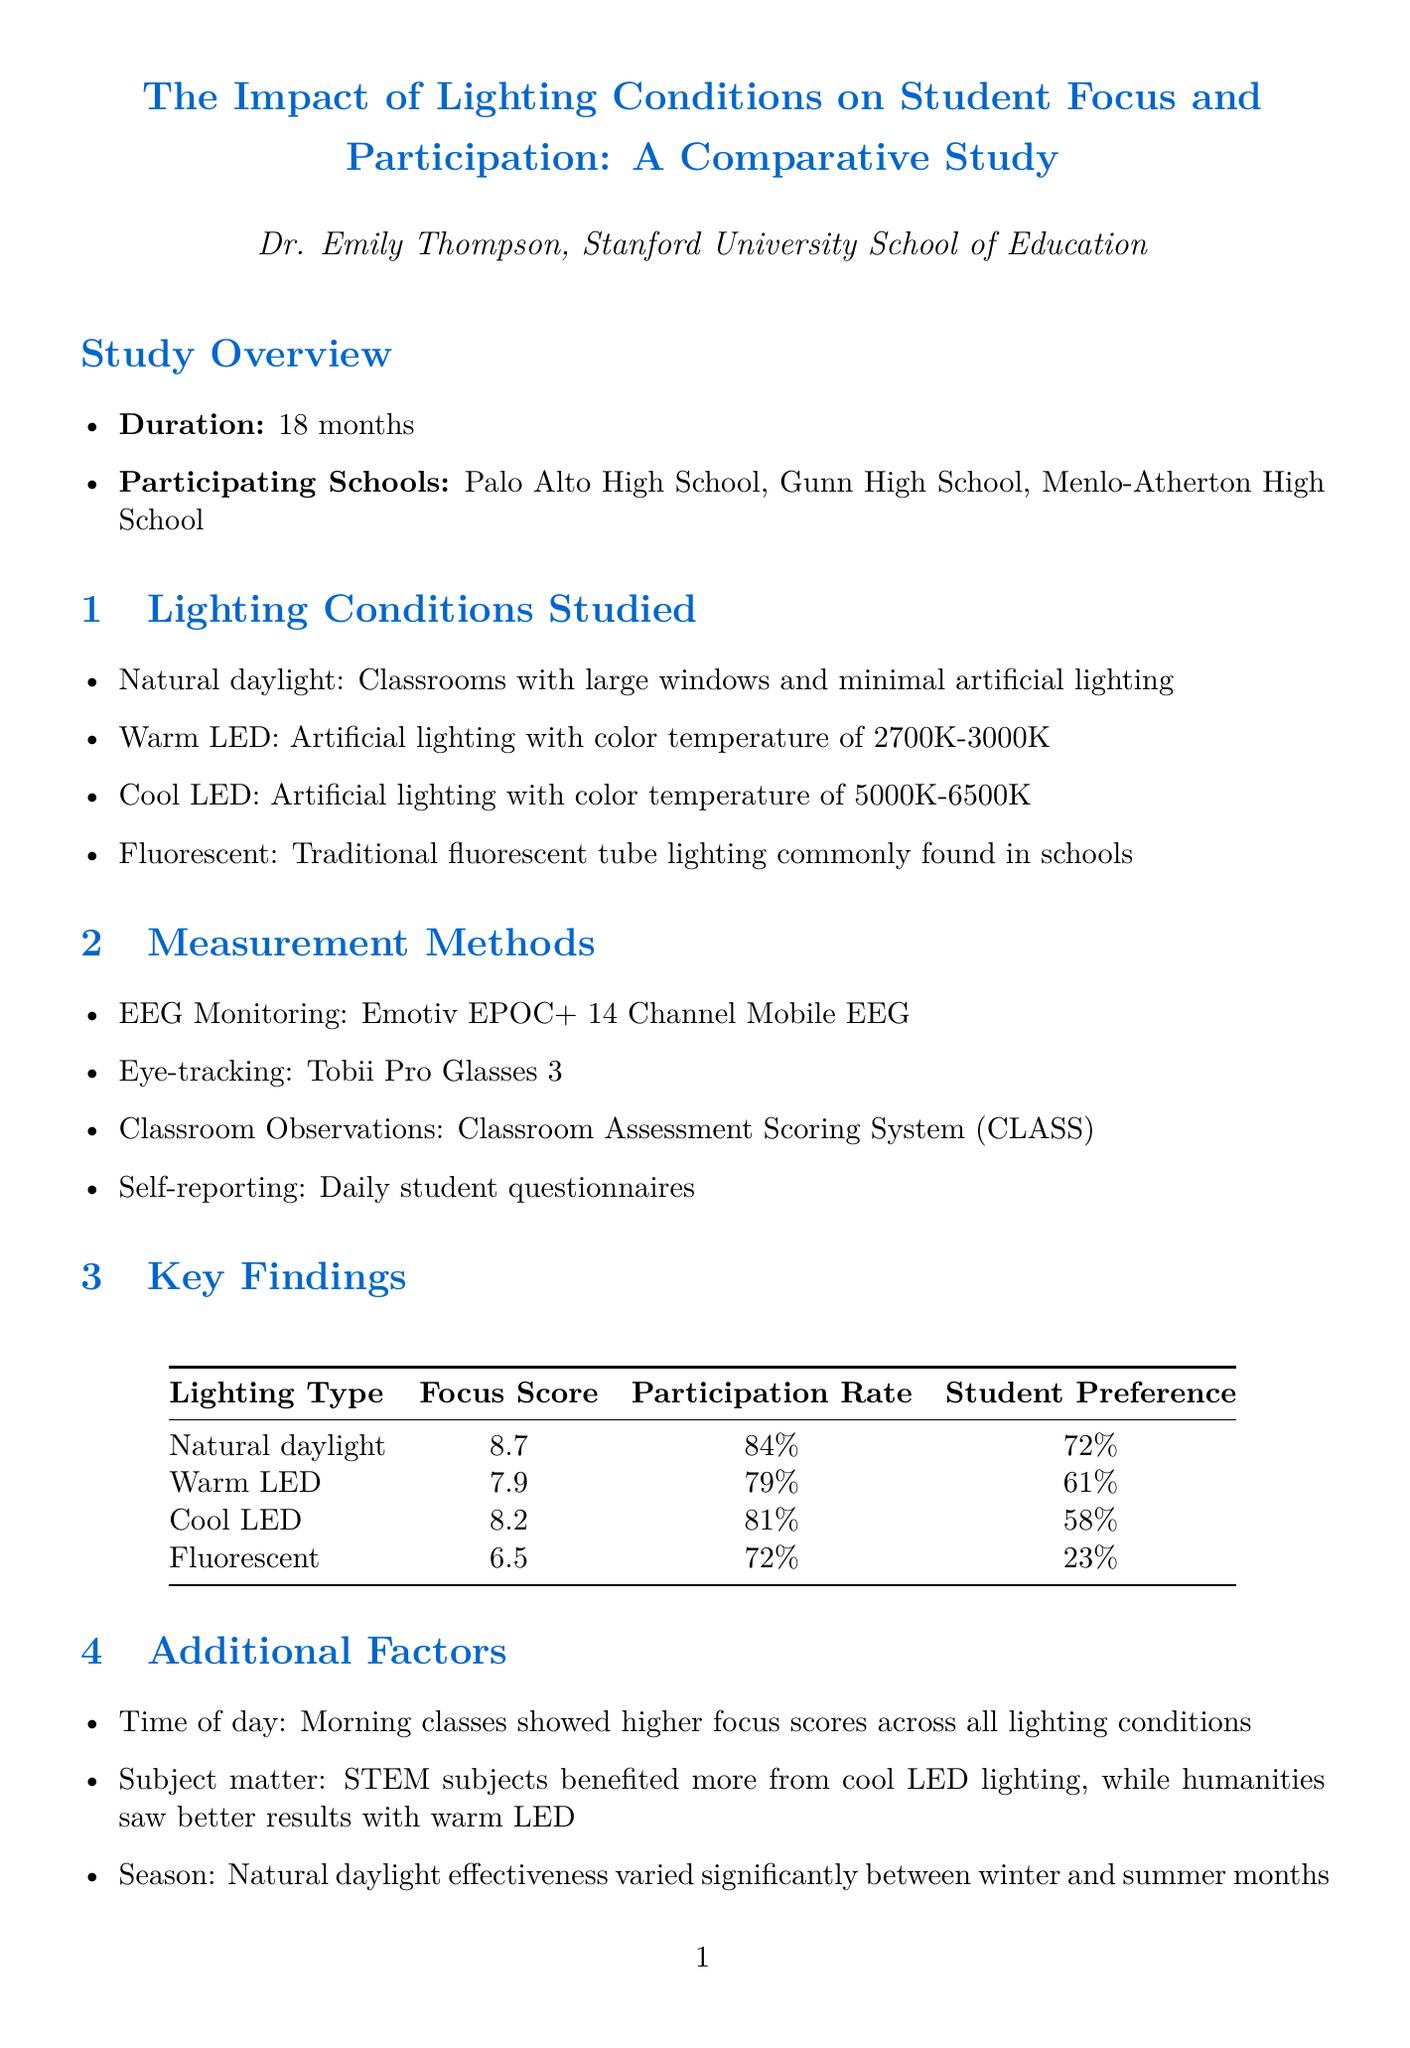What is the title of the study? The title is explicitly stated in the document, highlighting the focus on lighting conditions and their impact on student focus and participation.
Answer: The Impact of Lighting Conditions on Student Focus and Participation: A Comparative Study Who is the lead researcher? The document specifies the lead researcher's name, which is crucial for identifying who conducted the study.
Answer: Dr. Emily Thompson How many months did the study last? The document mentions the duration of the study, which is an important aspect of research timelines.
Answer: 18 months What is the participation rate for classrooms with natural daylight? This figure is provided in the findings section, indicating a specific metric for effectiveness.
Answer: 84% Which lighting type received the lowest focus score? By evaluating the key findings in the document, this answer highlights the least effective lighting condition based on the study's measurements.
Answer: Fluorescent What additional factor influenced student focus more during morning classes? The document lists various factors that impact focus, with this particular one emphasizing time of day.
Answer: Time of day What was the student preference percentage for fluorescent lighting? This information is found in the table of key findings, indicating students' opinions on different lighting types.
Answer: 23% Which lighting type benefited STEM subjects more? This finding requires synthesizing information from the additional factors section, focusing on subject matter performance.
Answer: Cool LED What is one recommendation for classroom lighting improvements? Recommendations in the document are provided to enhance classroom design, focusing on effective interventions.
Answer: Prioritize natural daylight in classroom design and renovation projects 